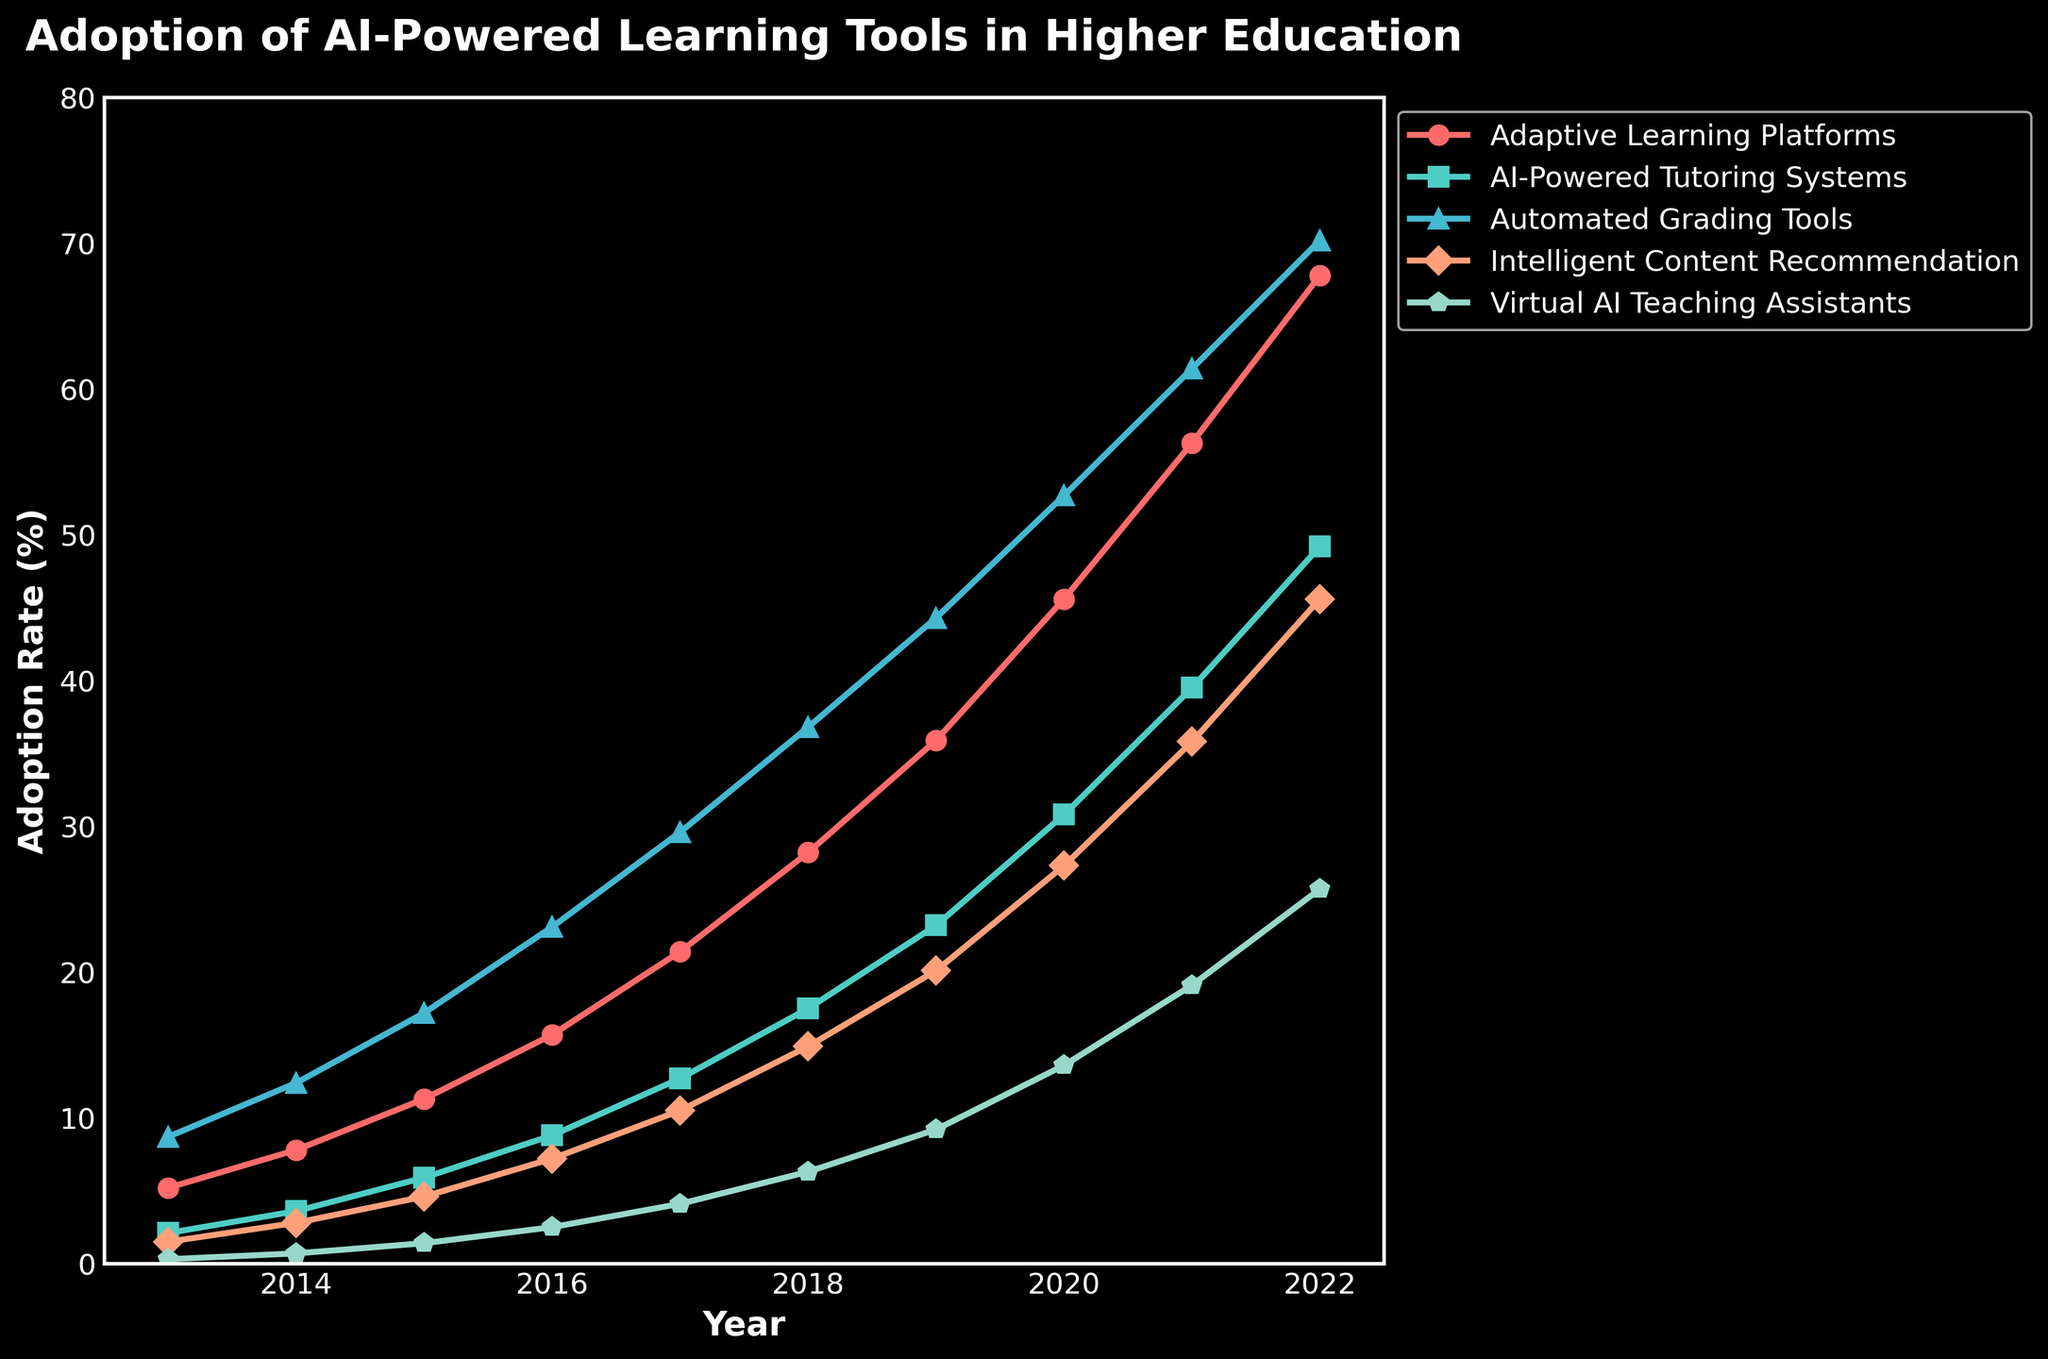what was the adoption rate of Adaptive Learning Platforms in 2017? Refer to the 2017 data point for Adaptive Learning Platforms, which shows an adoption rate of 21.4%.
Answer: 21.4% what is the overall trend in the adoption rates of AI-Powered Tutoring Systems from 2013 to 2022? Observe the plot line for AI-Powered Tutoring Systems. The line steadily increases year by year, indicating a consistent upward trend in adoption rates.
Answer: Increasing How much did the adoption rate for Virtual AI Teaching Assistants increase from 2013 to 2022? Subtract the 2013 adoption rate for Virtual AI Teaching Assistants (0.3%) from the 2022 adoption rate (25.7%). 25.7% - 0.3% = 25.4%.
Answer: 25.4% In which year did Automated Grading Tools surpass a 50% adoption rate? Look at the plot line for Automated Grading Tools. It crosses the 50% mark in the year 2020.
Answer: 2020 Which AI-powered learning tool had the lowest adoption rate in 2019? Compare all the 2019 data points. Virtual AI Teaching Assistants had the lowest adoption rate at 9.2%.
Answer: Virtual AI Teaching Assistants What is the difference in the adoption rate of Intelligent Content Recommendation from 2015 to 2020? Subtract the 2015 adoption rate (4.6%) from the 2020 adoption rate (27.3%). 27.3% - 4.6% = 22.7%.
Answer: 22.7% By how much did the adoption rate for AI-Powered Tutoring Systems grow between 2016 and 2018? Subtract the 2016 adoption rate (8.8%) from the 2018 adoption rate (17.5%). 17.5% - 8.8% = 8.7%.
Answer: 8.7% Which year witnessed the largest year-over-year increase in the adoption rate of Adaptive Learning Platforms? Observe the increases year-over-year for Adaptive Learning Platforms. The largest increase occurred between 2021 (56.3%) and 2022 (67.8%), which is 11.5%.
Answer: 2022 How does the adoption rate of Intelligent Content Recommendation in 2016 compare to Virtual AI Teaching Assistants in 2020? Refer to the 2016 data for Intelligent Content Recommendation (7.2%) and the 2020 data for Virtual AI Teaching Assistants (13.6%). The adoption rate in 2020 for Virtual AI Teaching Assistants is higher.
Answer: Virtual AI Teaching Assistants in 2020 is higher Which AI-powered learning tool had the highest adoption rate in 2021? Compare the 2021 data points for all AI-powered learning tools. Adaptive Learning Platforms had the highest adoption rate at 56.3%.
Answer: Adaptive Learning Platforms 